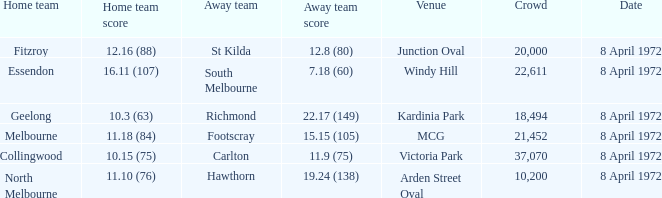Which Venue has a Home team of geelong? Kardinia Park. 